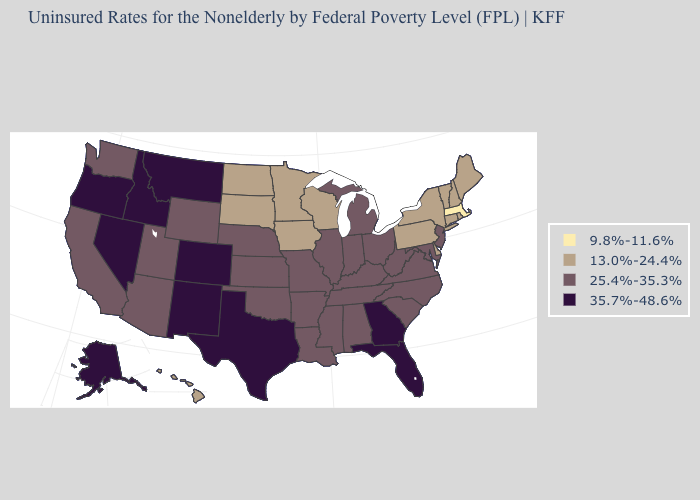What is the lowest value in the USA?
Keep it brief. 9.8%-11.6%. Does Georgia have the same value as Colorado?
Short answer required. Yes. What is the value of Illinois?
Be succinct. 25.4%-35.3%. Does Alaska have the same value as Montana?
Quick response, please. Yes. Name the states that have a value in the range 25.4%-35.3%?
Short answer required. Alabama, Arizona, Arkansas, California, Illinois, Indiana, Kansas, Kentucky, Louisiana, Maryland, Michigan, Mississippi, Missouri, Nebraska, New Jersey, North Carolina, Ohio, Oklahoma, South Carolina, Tennessee, Utah, Virginia, Washington, West Virginia, Wyoming. What is the lowest value in the West?
Keep it brief. 13.0%-24.4%. What is the value of Wisconsin?
Short answer required. 13.0%-24.4%. Does Florida have a higher value than Nevada?
Write a very short answer. No. What is the lowest value in the USA?
Quick response, please. 9.8%-11.6%. Name the states that have a value in the range 25.4%-35.3%?
Concise answer only. Alabama, Arizona, Arkansas, California, Illinois, Indiana, Kansas, Kentucky, Louisiana, Maryland, Michigan, Mississippi, Missouri, Nebraska, New Jersey, North Carolina, Ohio, Oklahoma, South Carolina, Tennessee, Utah, Virginia, Washington, West Virginia, Wyoming. Does Utah have the highest value in the USA?
Quick response, please. No. What is the value of Louisiana?
Keep it brief. 25.4%-35.3%. What is the lowest value in states that border New Jersey?
Give a very brief answer. 13.0%-24.4%. Name the states that have a value in the range 13.0%-24.4%?
Answer briefly. Connecticut, Delaware, Hawaii, Iowa, Maine, Minnesota, New Hampshire, New York, North Dakota, Pennsylvania, Rhode Island, South Dakota, Vermont, Wisconsin. 